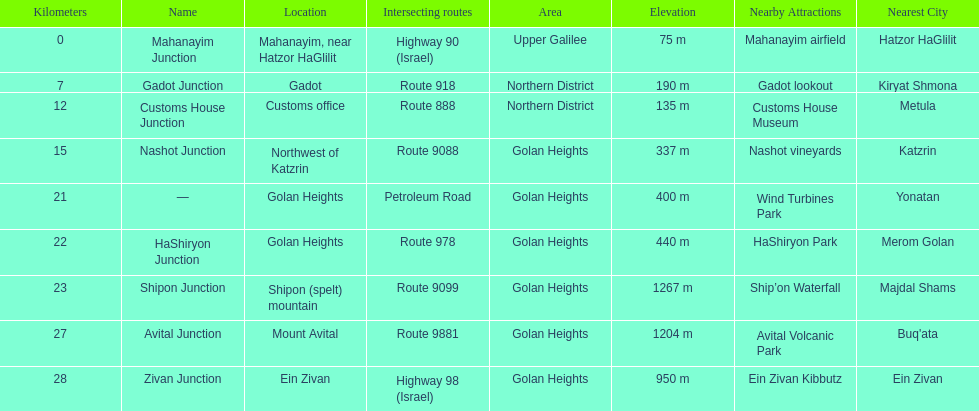Which junction on highway 91 is closer to ein zivan, gadot junction or shipon junction? Gadot Junction. 